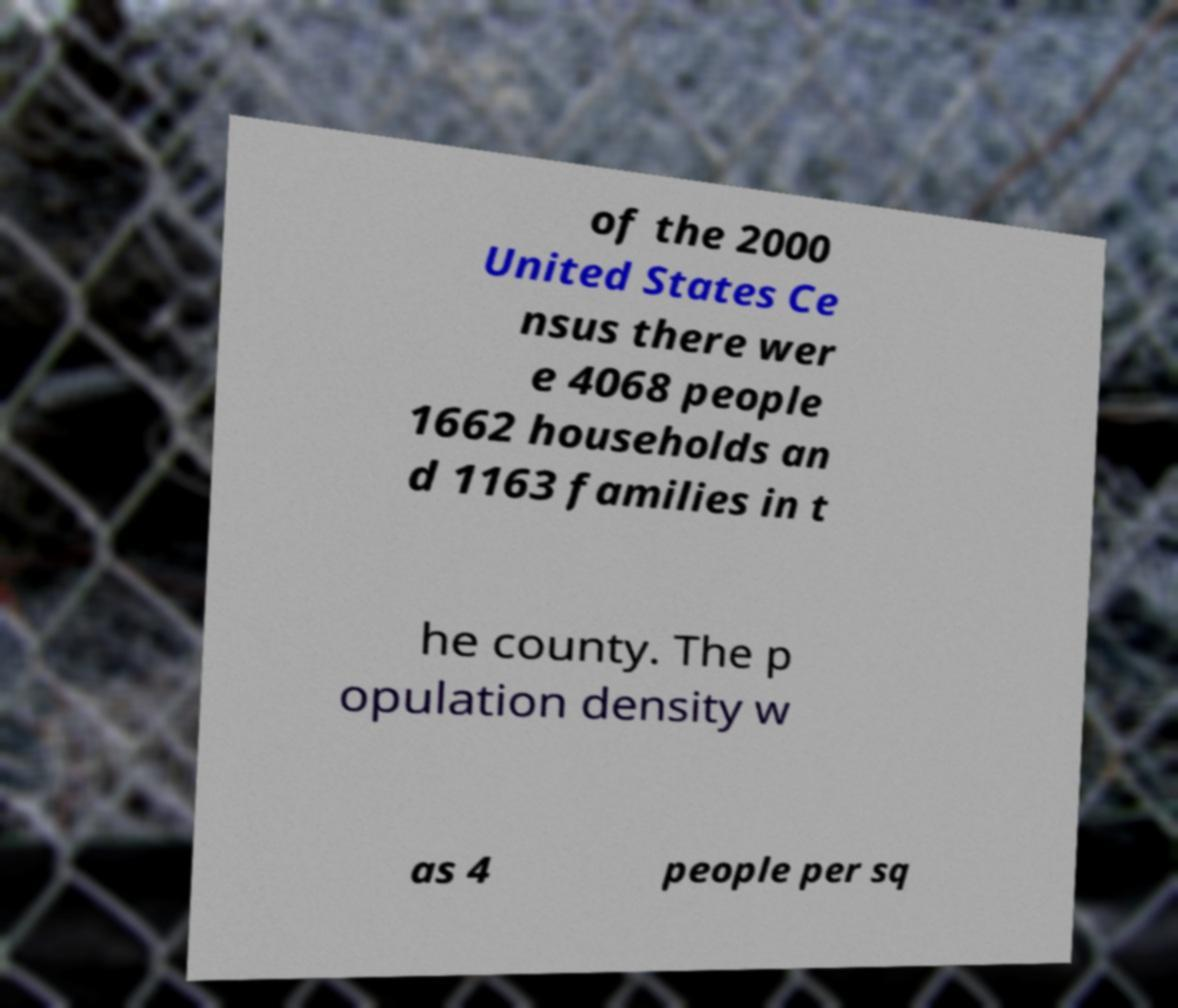I need the written content from this picture converted into text. Can you do that? of the 2000 United States Ce nsus there wer e 4068 people 1662 households an d 1163 families in t he county. The p opulation density w as 4 people per sq 